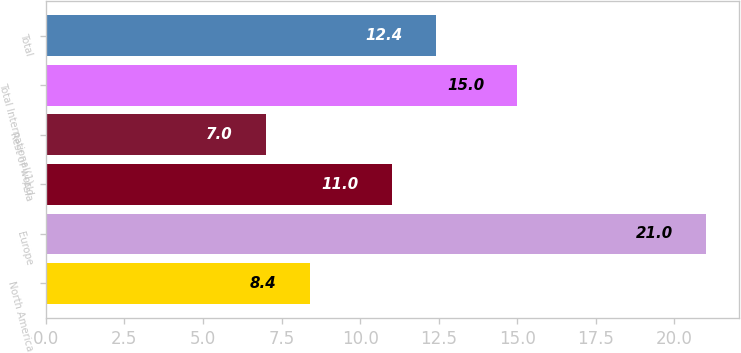<chart> <loc_0><loc_0><loc_500><loc_500><bar_chart><fcel>North America<fcel>Europe<fcel>Asia<fcel>Rest of world<fcel>Total International(1)<fcel>Total<nl><fcel>8.4<fcel>21<fcel>11<fcel>7<fcel>15<fcel>12.4<nl></chart> 